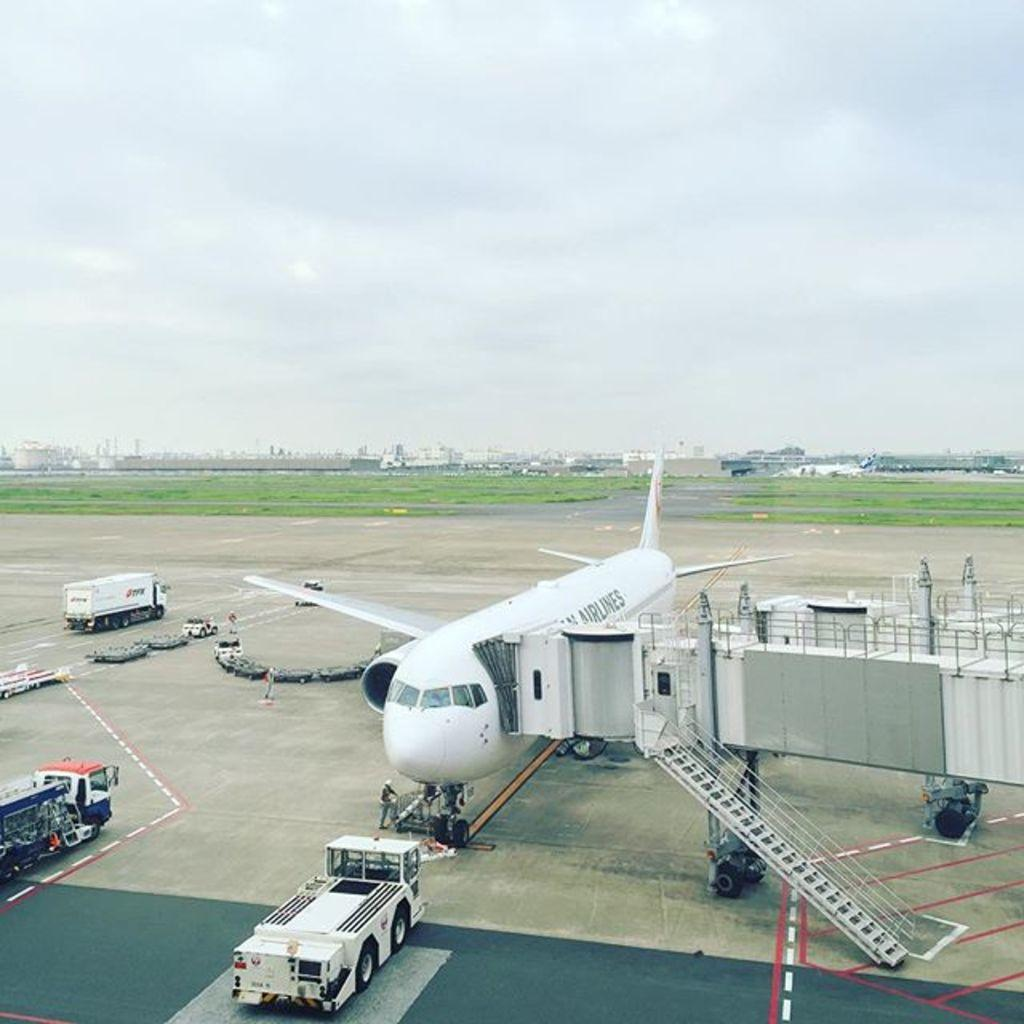What is the main subject of the image? The main subject of the image is an airplane. What other types of transportation can be seen in the image? There are vehicles in the image. Can you describe any architectural features in the image? Yes, there is a staircase in the image. Who or what else is present in the image? There is a person standing in the image. What is on the ground in the image? There are objects on the ground in the image. What can be seen in the background of the image? There is grass, buildings, and the sky visible in the background of the image. What type of waves can be seen in the image? There are no waves present in the image. What is the person reading in the image? There is no indication that the person is reading anything in the image. 